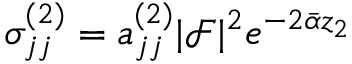<formula> <loc_0><loc_0><loc_500><loc_500>\sigma _ { j j } ^ { ( 2 ) } = a _ { j j } ^ { ( 2 ) } | \mathcal { F } | ^ { 2 } e ^ { - 2 \bar { \alpha } z _ { 2 } }</formula> 